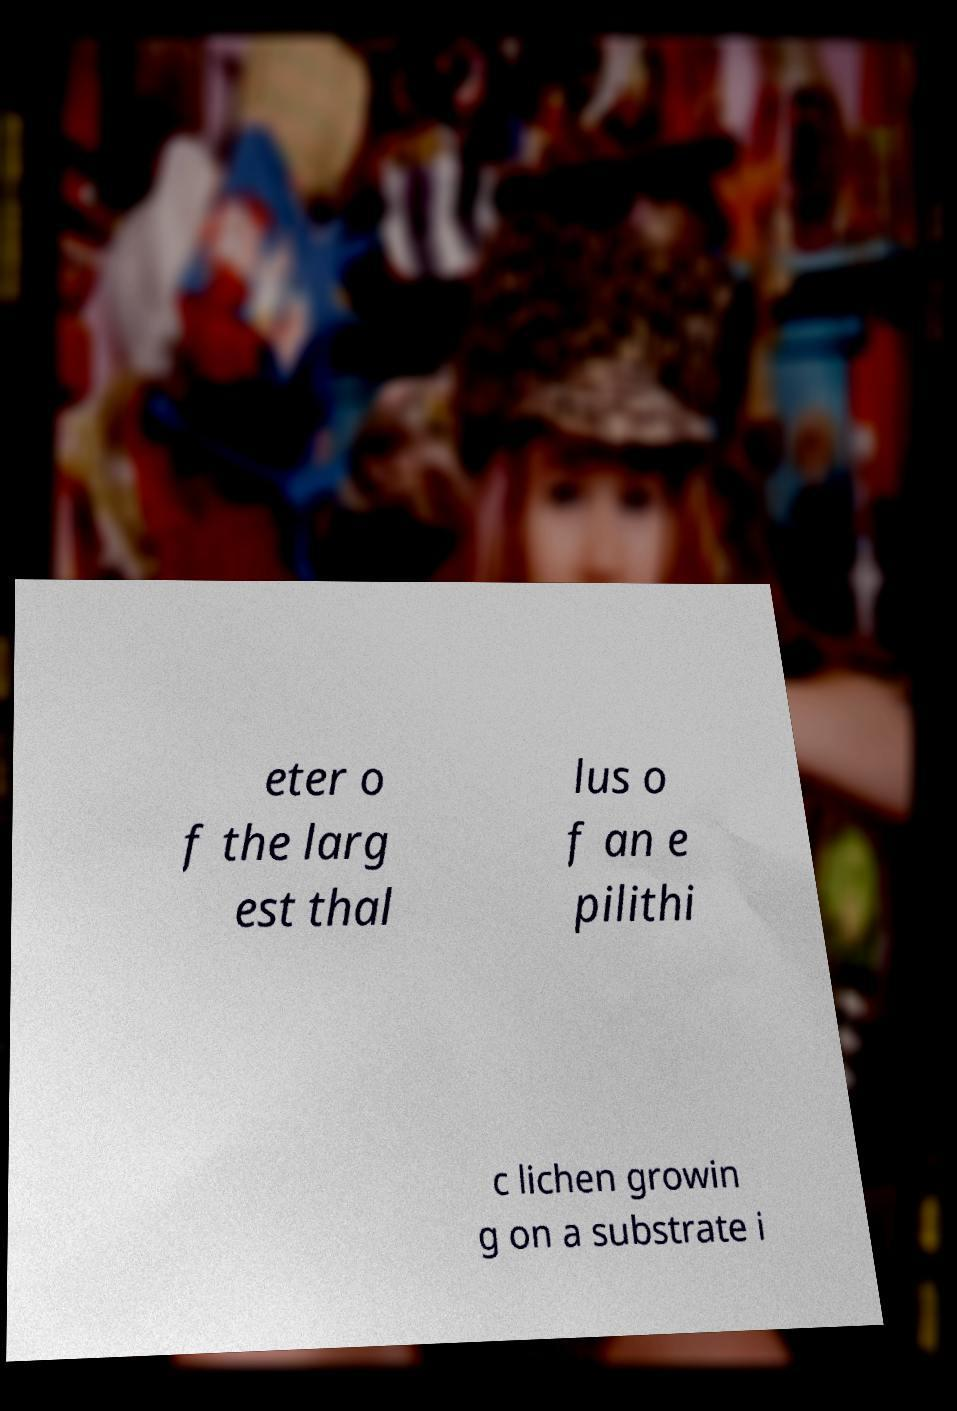For documentation purposes, I need the text within this image transcribed. Could you provide that? eter o f the larg est thal lus o f an e pilithi c lichen growin g on a substrate i 